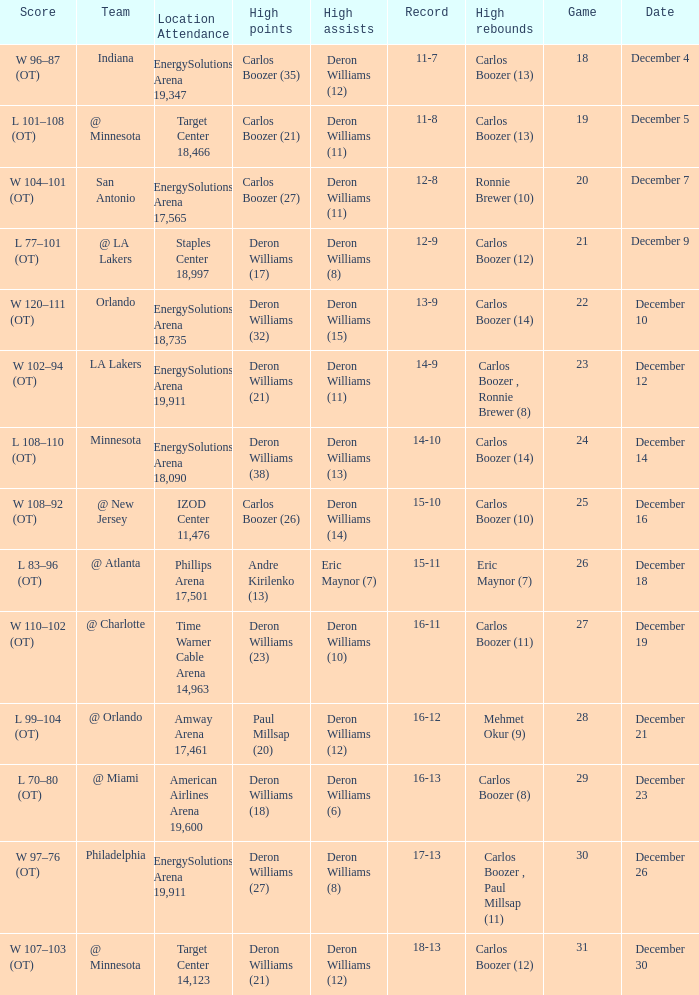How many different high rebound results are there for the game number 26? 1.0. 